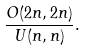<formula> <loc_0><loc_0><loc_500><loc_500>\frac { O ( 2 n , 2 n ) } { U ( n , n ) } .</formula> 